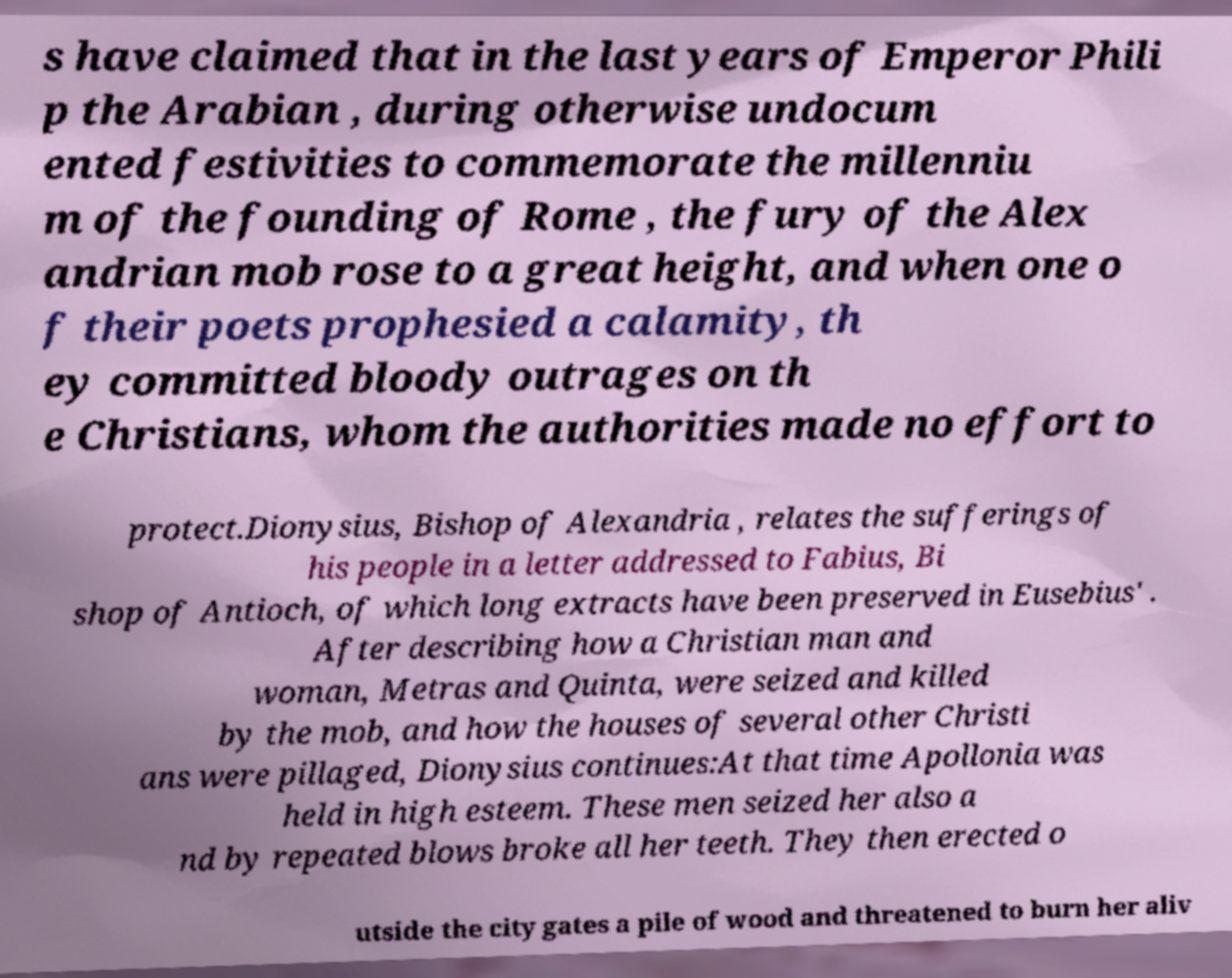Could you extract and type out the text from this image? s have claimed that in the last years of Emperor Phili p the Arabian , during otherwise undocum ented festivities to commemorate the millenniu m of the founding of Rome , the fury of the Alex andrian mob rose to a great height, and when one o f their poets prophesied a calamity, th ey committed bloody outrages on th e Christians, whom the authorities made no effort to protect.Dionysius, Bishop of Alexandria , relates the sufferings of his people in a letter addressed to Fabius, Bi shop of Antioch, of which long extracts have been preserved in Eusebius' . After describing how a Christian man and woman, Metras and Quinta, were seized and killed by the mob, and how the houses of several other Christi ans were pillaged, Dionysius continues:At that time Apollonia was held in high esteem. These men seized her also a nd by repeated blows broke all her teeth. They then erected o utside the city gates a pile of wood and threatened to burn her aliv 